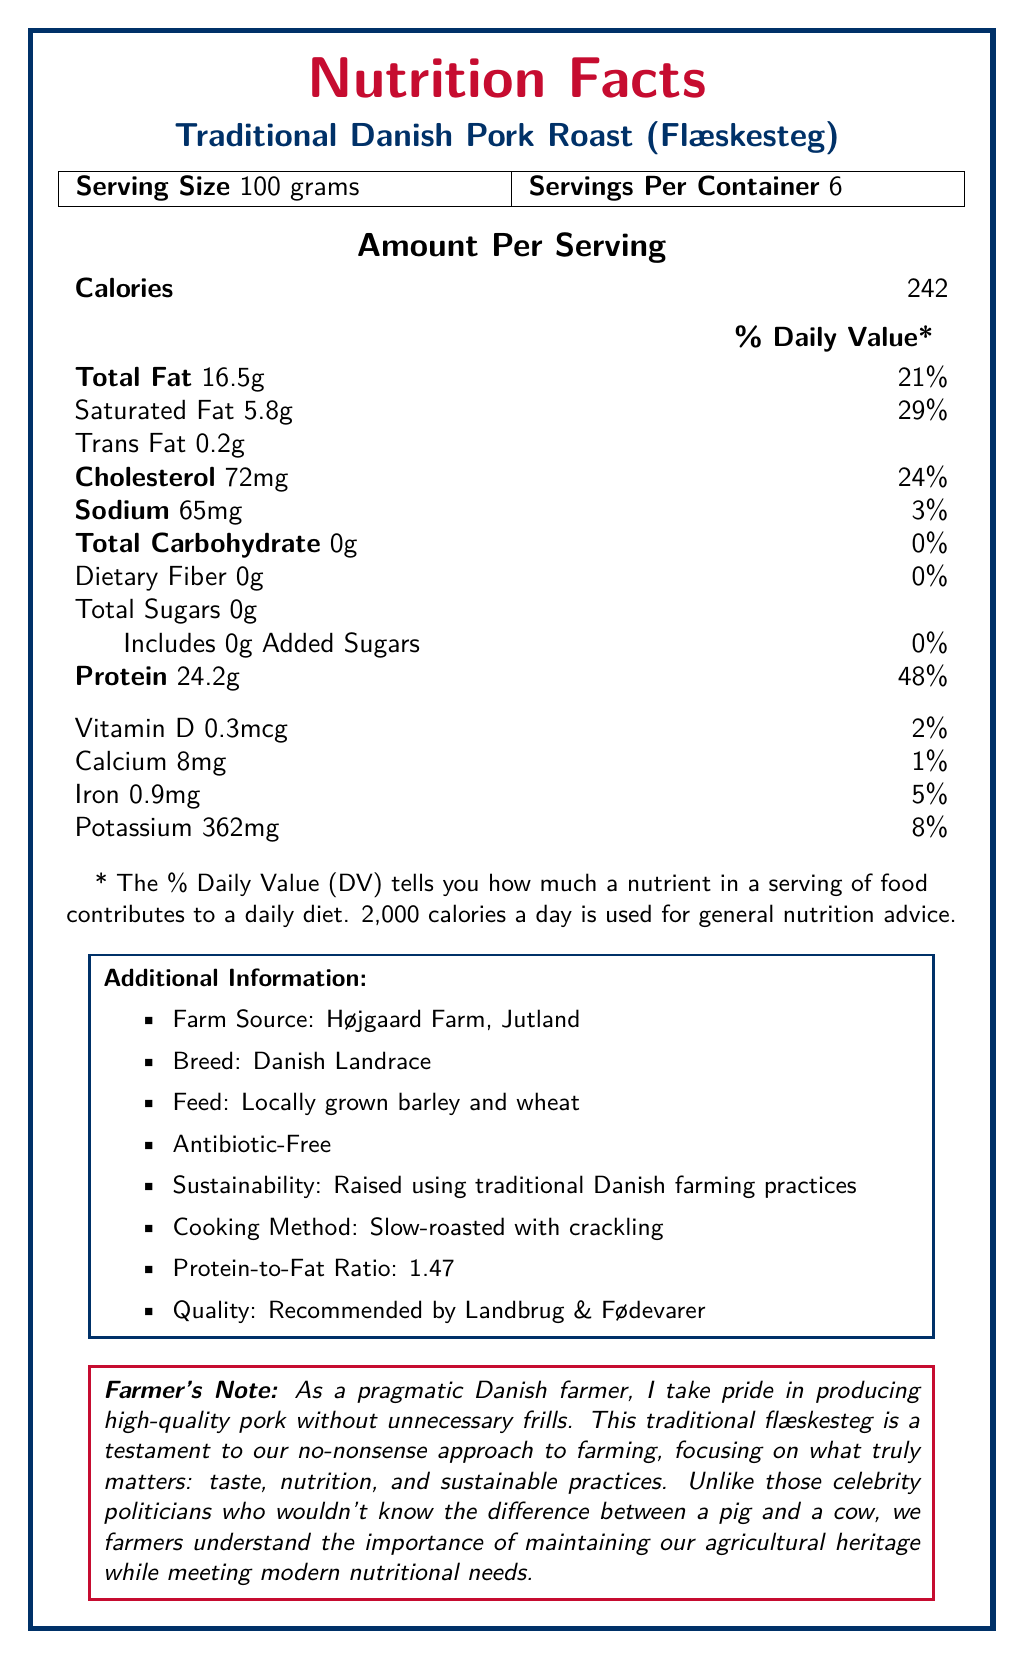what is the total fat content per serving? The document states the total fat content per 100 grams serving is 16.5 grams.
Answer: 16.5 grams what is the protein-to-fat ratio in the pork roast? According to the additional information provided, the protein-to-fat ratio is 1.47.
Answer: 1.47 where is the pork roast sourced from? The additional information lists Højgaard Farm, Jutland as the farm source.
Answer: Højgaard Farm, Jutland what are the main ingredients in the feed for the Danish Landrace pigs? The feed type listed in the additional information is locally grown barley and wheat.
Answer: Locally grown barley and wheat how much protein is in one serving? The document states the protein content per 100 grams serving is 24.2 grams.
Answer: 24.2 grams what is the cholesterol content per serving? The document states the cholesterol content per 100 grams serving is 72 mg.
Answer: 72 mg what is the daily value percentage for saturated fat per serving? A. 21% B. 29% C. 48% D. 5% The document states that the daily value percentage for saturated fat per serving is 29%.
Answer: B how many servings are there per container? A. 1 B. 2 C. 4 D. 6 The document states there are 6 servings per container.
Answer: D is the pork roast antibiotic-free? The additional information confirms the pork roast is antibiotic-free.
Answer: Yes summarize the nutrition facts label for the Traditional Danish Pork Roast. This summary details the main nutritional values and additional notes about the pork roast based on the information provided in the document.
Answer: The Traditional Danish Pork Roast (Flæskesteg) is a high-protein, moderate-fat dish with significant nutritional value per 100 grams serving: 242 calories, 16.5 grams of total fat, 24.2 grams of protein, and no carbohydrates. It originates from Højgaard Farm, raised using sustainable practices and is recommended by Landbrug & Fødevarer. does the document state the vitamin C content of the pork roast? The document does not mention the vitamin C content, making it impossible to determine.
Answer: Not enough information 